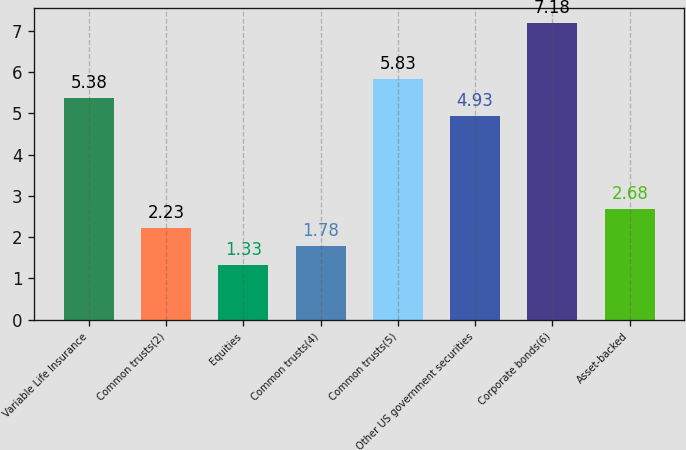Convert chart to OTSL. <chart><loc_0><loc_0><loc_500><loc_500><bar_chart><fcel>Variable Life Insurance<fcel>Common trusts(2)<fcel>Equities<fcel>Common trusts(4)<fcel>Common trusts(5)<fcel>Other US government securities<fcel>Corporate bonds(6)<fcel>Asset-backed<nl><fcel>5.38<fcel>2.23<fcel>1.33<fcel>1.78<fcel>5.83<fcel>4.93<fcel>7.18<fcel>2.68<nl></chart> 